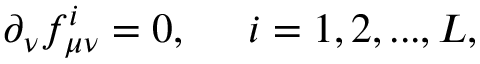Convert formula to latex. <formula><loc_0><loc_0><loc_500><loc_500>\partial _ { \nu } f _ { \mu \nu } ^ { i } = 0 , \, i = 1 , 2 , \dots , L ,</formula> 